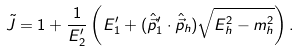Convert formula to latex. <formula><loc_0><loc_0><loc_500><loc_500>\tilde { J } = 1 + \frac { 1 } { E _ { 2 } ^ { \prime } } \left ( E _ { 1 } ^ { \prime } + ( \hat { \vec { p } } _ { 1 } ^ { \prime } \cdot \hat { \vec { p } } _ { h } ) \sqrt { E _ { h } ^ { 2 } - m _ { h } ^ { 2 } } \right ) .</formula> 